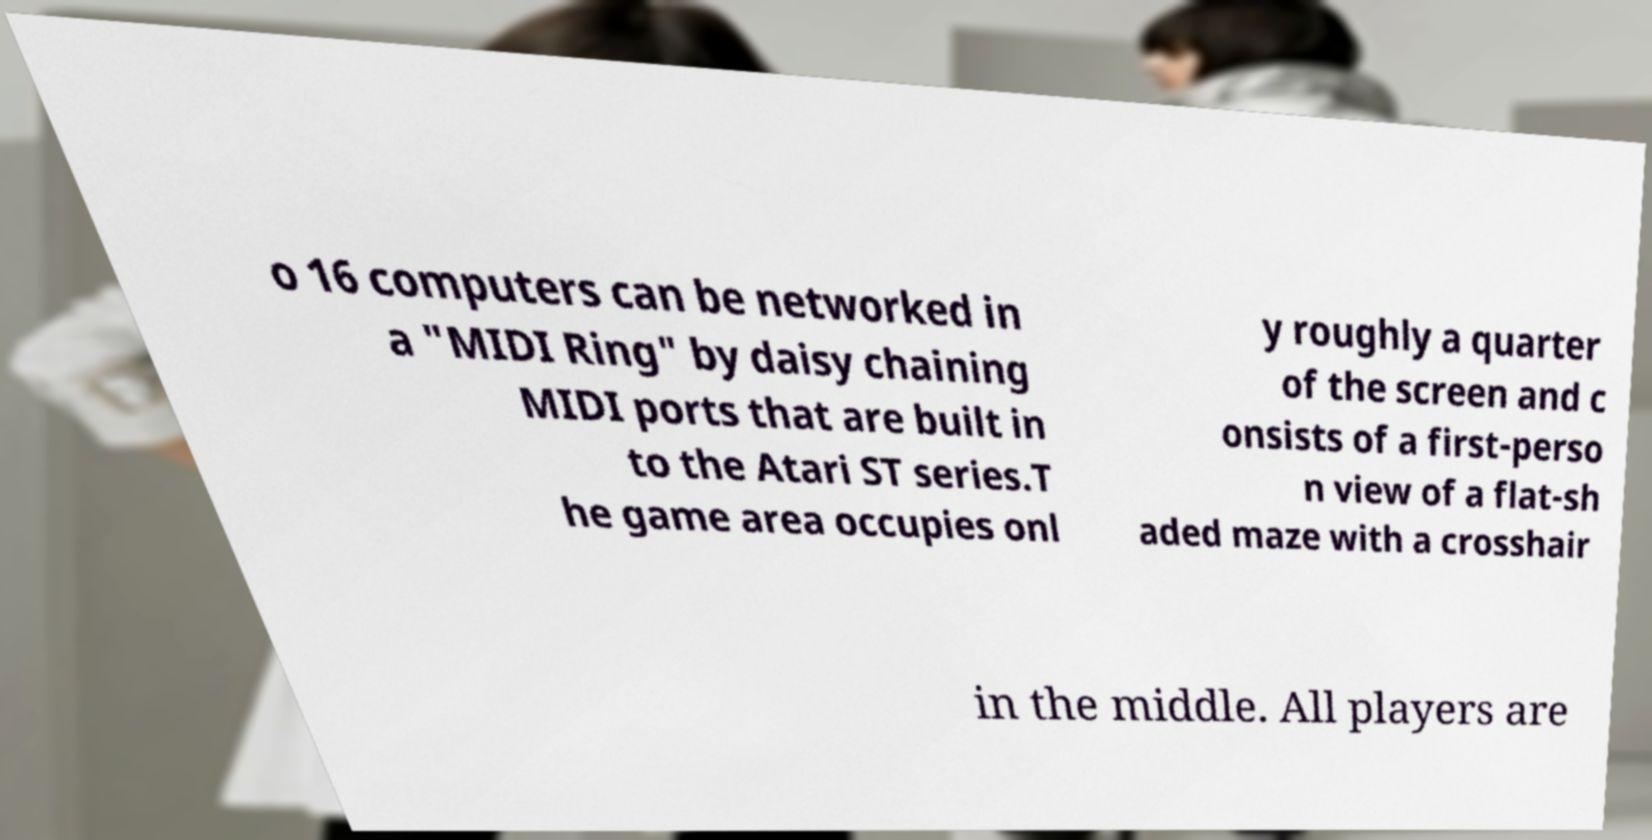I need the written content from this picture converted into text. Can you do that? o 16 computers can be networked in a "MIDI Ring" by daisy chaining MIDI ports that are built in to the Atari ST series.T he game area occupies onl y roughly a quarter of the screen and c onsists of a first-perso n view of a flat-sh aded maze with a crosshair in the middle. All players are 